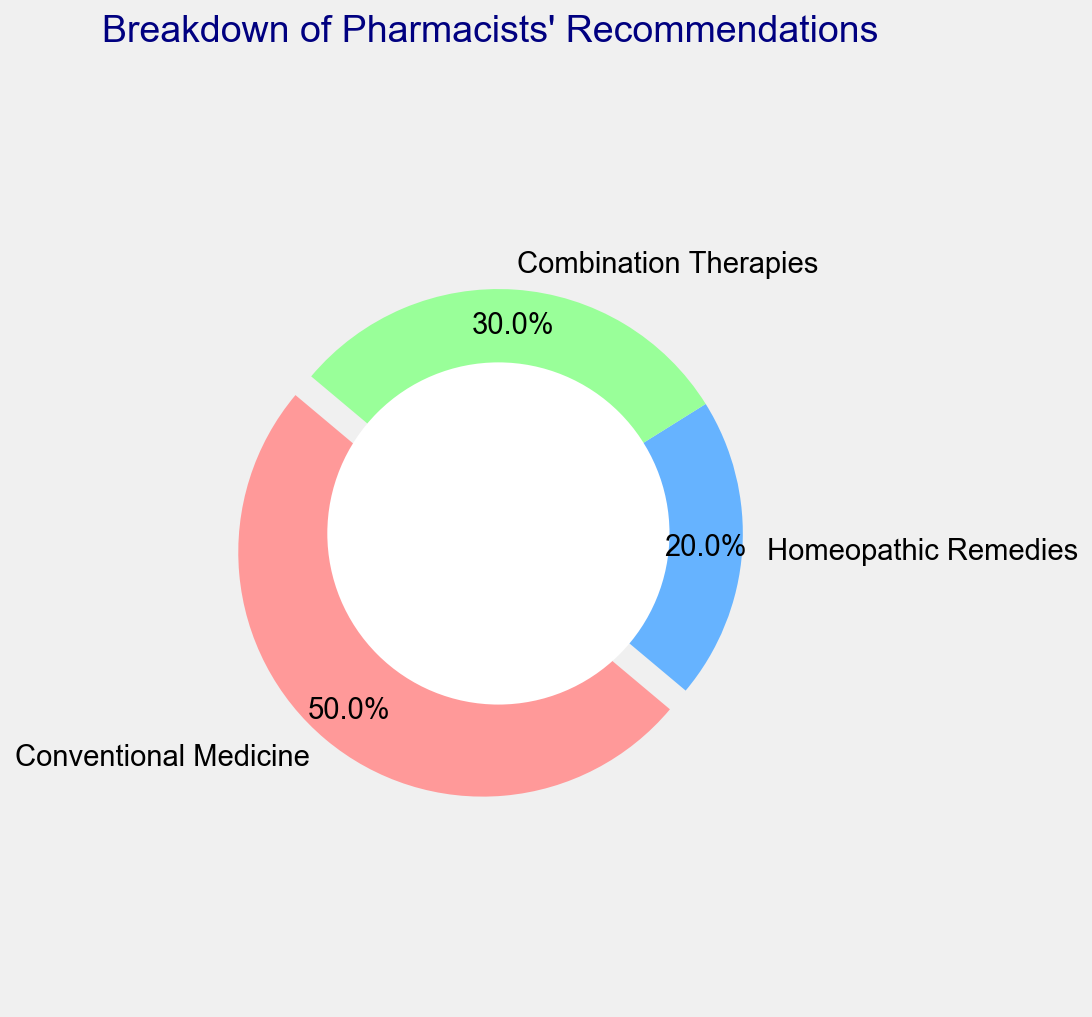what is the most recommended option according to the pie chart? The largest slice of the pie chart represents the most recommended option. In this case, "Conventional Medicine" has the largest slice with 50%.
Answer: Conventional Medicine How much more popular is Conventional Medicine than Homeopathic Remedies? The percentage for Conventional Medicine is 50%, and for Homeopathic Remedies it is 20%. The difference is 50% - 20% = 30%.
Answer: 30% What fraction of the total recommendations is made up by Combination Therapies? The pie chart shows that Combination Therapies-account for 30% of the total. 30% of 100% is 30/100 or 3/10.
Answer: 3/10 What is the combined percentage of Homeopathic Remedies and Combination Therapies? The percentages for Homeopathic Remedies and Combination Therapies are 20% and 30%, respectively. Adding them gives 20% + 30% = 50%.
Answer: 50% Which segment of the pie chart is visually distinguished by being separated from the rest? The pie chart uses an exploded slice to highlight a segment. The Conventional Medicine slice is separated from the rest, making it visually distinct.
Answer: Conventional Medicine What percentage of recommendations do not involve conventional medicine alone? Sum the percentages of Homeopathic Remedies and Combination Therapies. The percentages are 20% and 30%, respectively. So, 20% + 30% = 50%.
Answer: 50% If you combine the recommendations for Homeopathic Remedies and Conventional Medicine, do they constitute a majority of the recommendations? The percentages for Homeopathic Remedies and Conventional Medicine are 20% and 50% respectively. Adding them up gives 20% + 50% = 70%, which is more than 50% and thus constitutes a majority.
Answer: Yes Describe the color scheme of the three categories shown in the pie chart. The Conventional Medicine segment is colored red, Homeopathic Remedies are colored blue, and Combination Therapies are colored green.
Answer: Red, blue, green How many categories have a percentage lower than 40%? From the pie chart, Homeopathic Remedies have 20% and Combination Therapies have 30%, both of which are lower than 40%. Thus, there are two such categories.
Answer: 2 